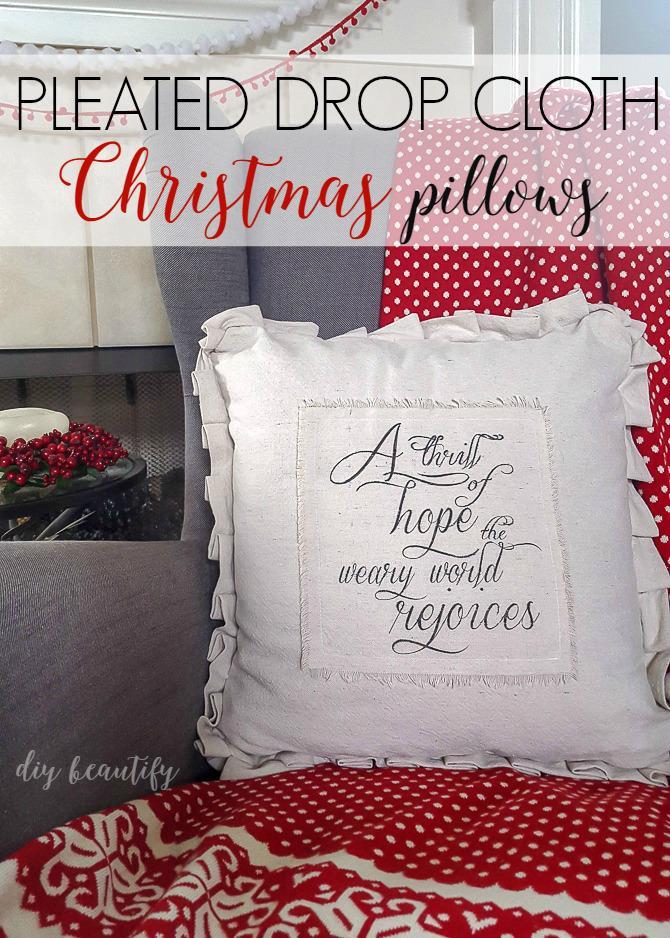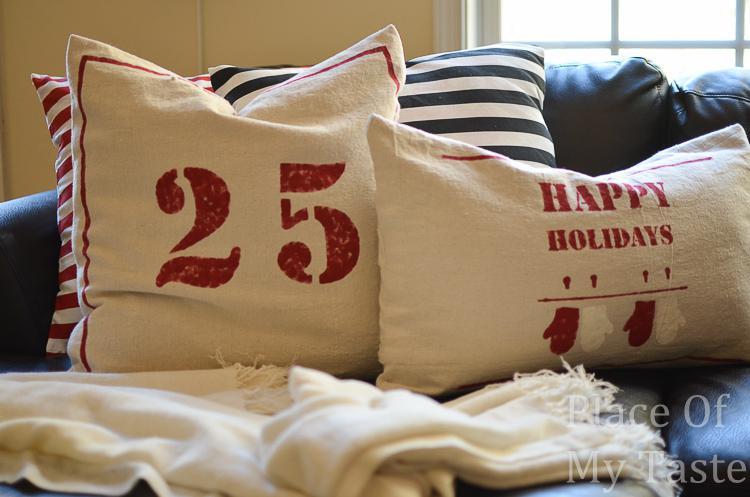The first image is the image on the left, the second image is the image on the right. For the images displayed, is the sentence "None of the pillows contain the number '25'." factually correct? Answer yes or no. No. The first image is the image on the left, the second image is the image on the right. Given the left and right images, does the statement "One image has a pillow with vertical strips going down the center." hold true? Answer yes or no. No. 